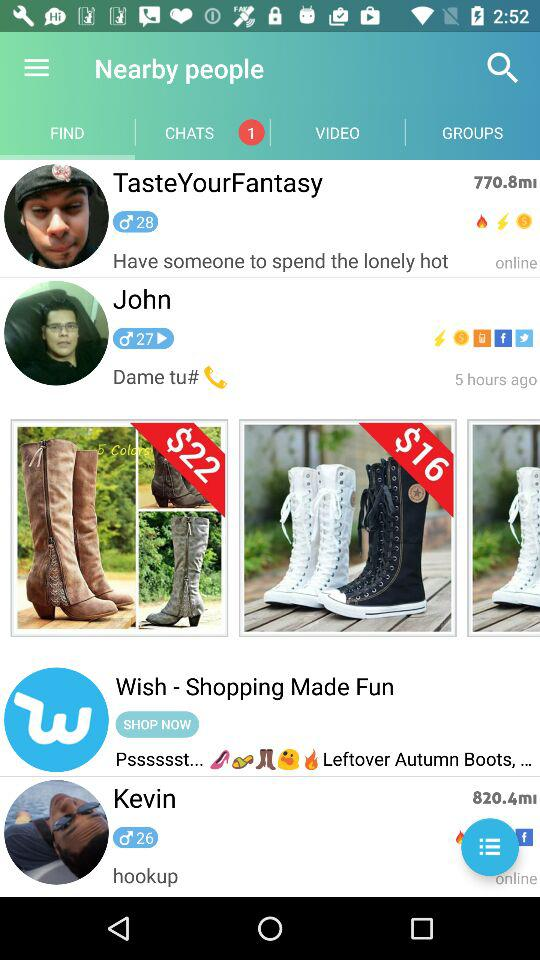What is the application name in the advertisement? The application name in the advertisement is "Wish - Shopping Made Fun". 